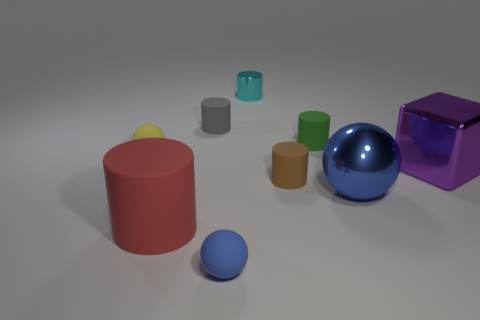Do the blue ball to the right of the green object and the large red object have the same material?
Make the answer very short. No. There is a gray cylinder that is the same size as the brown rubber cylinder; what is it made of?
Provide a short and direct response. Rubber. What number of other objects are the same material as the big purple cube?
Give a very brief answer. 2. There is a gray thing; does it have the same size as the cylinder that is behind the small gray rubber thing?
Ensure brevity in your answer.  Yes. Is the number of big purple things that are to the left of the tiny brown object less than the number of small brown matte cylinders behind the small cyan metallic cylinder?
Offer a terse response. No. There is a blue thing to the right of the brown thing; what size is it?
Provide a short and direct response. Large. Is the size of the metal sphere the same as the gray thing?
Your answer should be compact. No. How many large objects are to the right of the large blue metal thing and in front of the large purple shiny object?
Give a very brief answer. 0. What number of cyan objects are big balls or small matte spheres?
Make the answer very short. 0. What number of metallic things are cyan cylinders or green cylinders?
Keep it short and to the point. 1. 